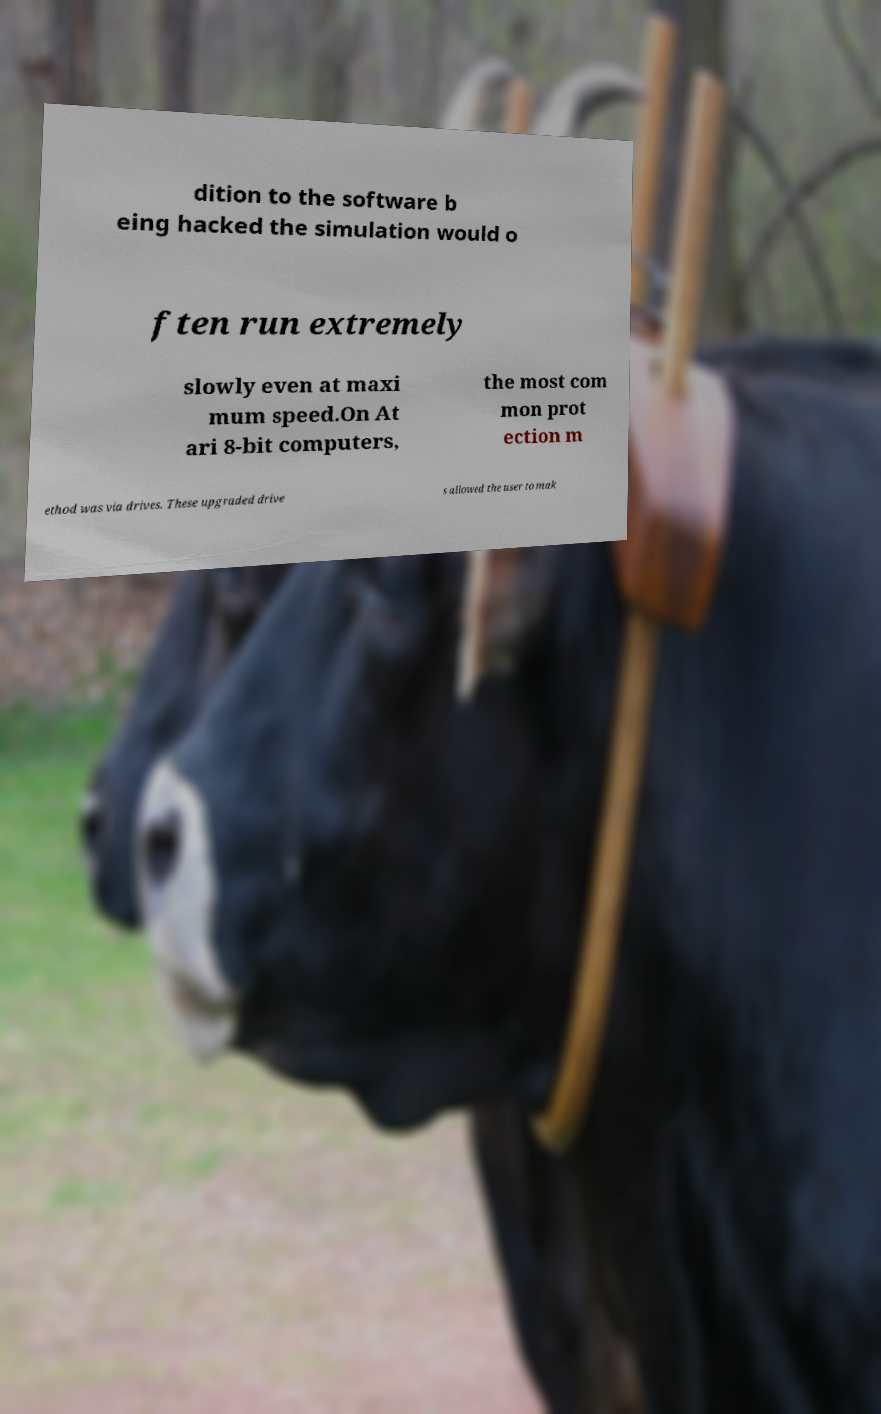Could you assist in decoding the text presented in this image and type it out clearly? dition to the software b eing hacked the simulation would o ften run extremely slowly even at maxi mum speed.On At ari 8-bit computers, the most com mon prot ection m ethod was via drives. These upgraded drive s allowed the user to mak 